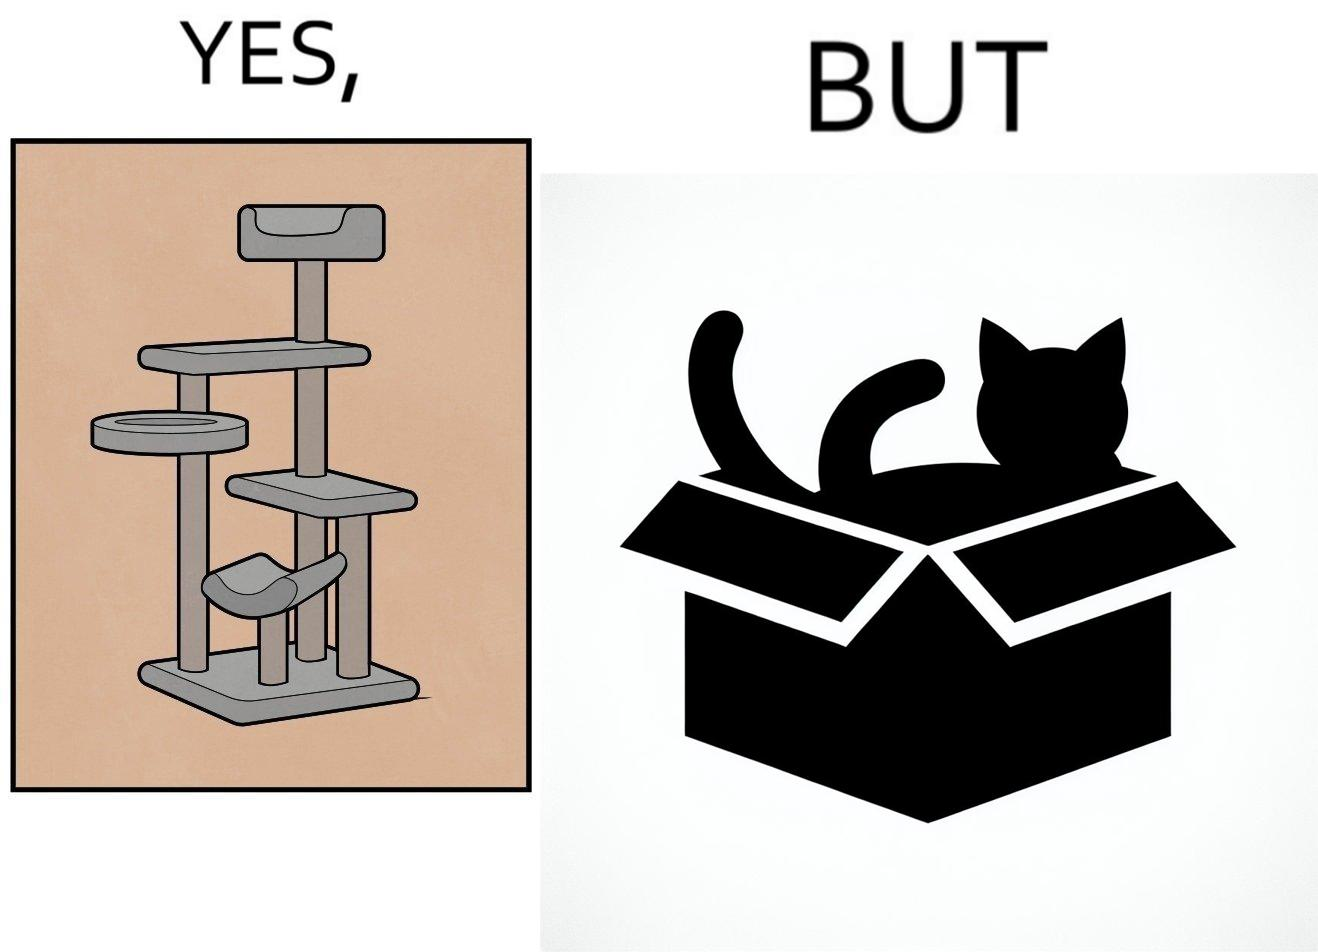What makes this image funny or satirical? The images are funny since even though a cat tree is bought for cats to play with, cats would usually rather play with inexpensive cardboard boxes because they enjoy it more 